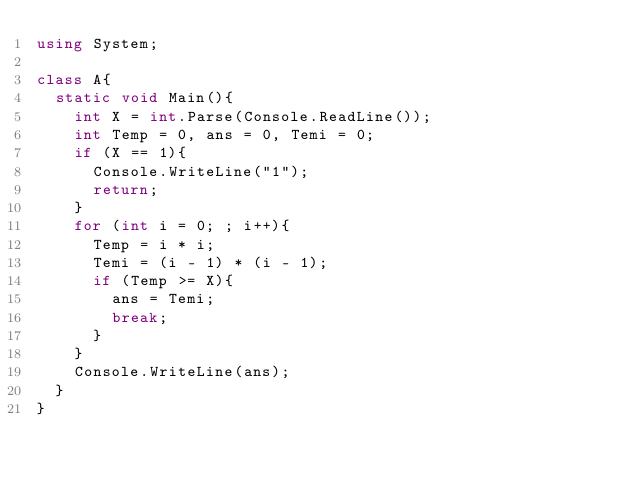<code> <loc_0><loc_0><loc_500><loc_500><_C#_>using System;

class A{
  static void Main(){
    int X = int.Parse(Console.ReadLine());
    int Temp = 0, ans = 0, Temi = 0;
    if (X == 1){
      Console.WriteLine("1");
      return;
    }
    for (int i = 0; ; i++){
      Temp = i * i;
      Temi = (i - 1) * (i - 1);
      if (Temp >= X){
        ans = Temi;
        break;
      }
    }
    Console.WriteLine(ans);
  }
}
</code> 